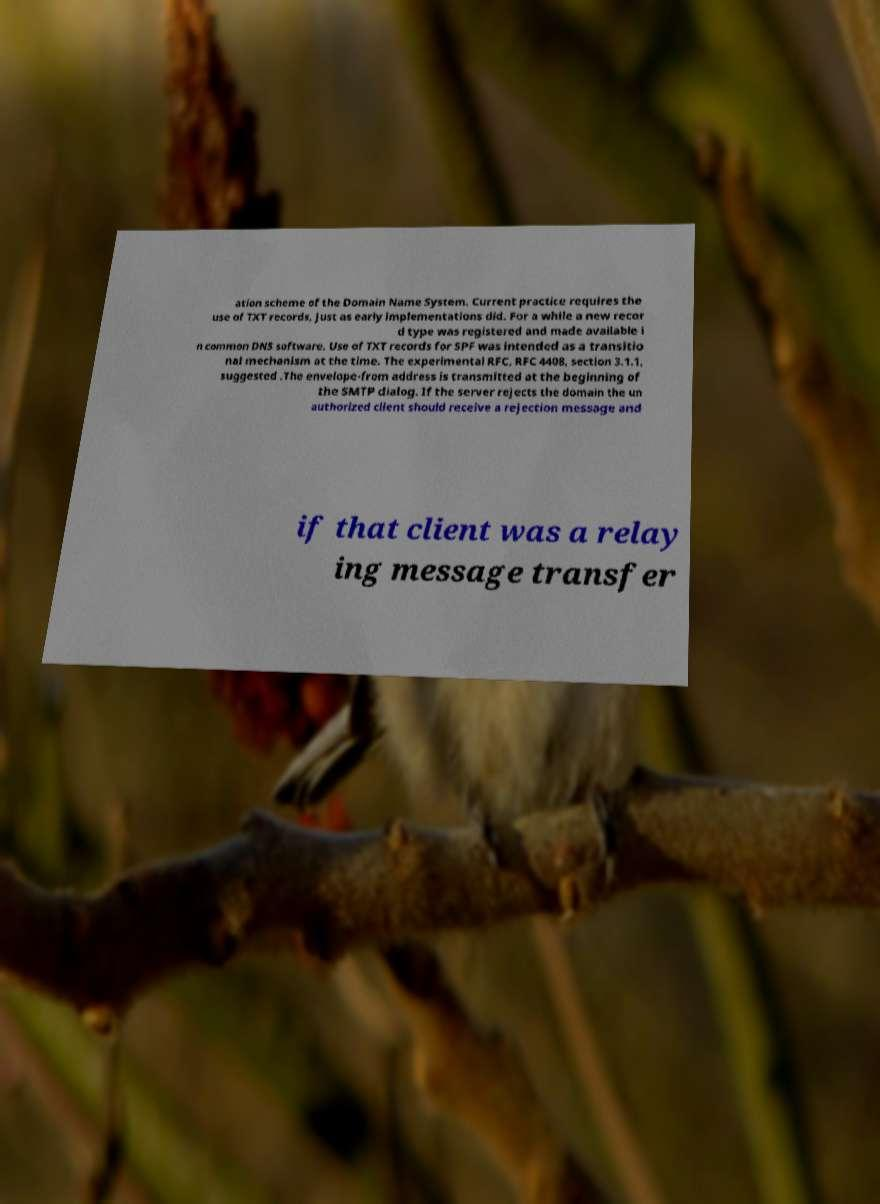Please read and relay the text visible in this image. What does it say? ation scheme of the Domain Name System. Current practice requires the use of TXT records, just as early implementations did. For a while a new recor d type was registered and made available i n common DNS software. Use of TXT records for SPF was intended as a transitio nal mechanism at the time. The experimental RFC, RFC 4408, section 3.1.1, suggested .The envelope-from address is transmitted at the beginning of the SMTP dialog. If the server rejects the domain the un authorized client should receive a rejection message and if that client was a relay ing message transfer 